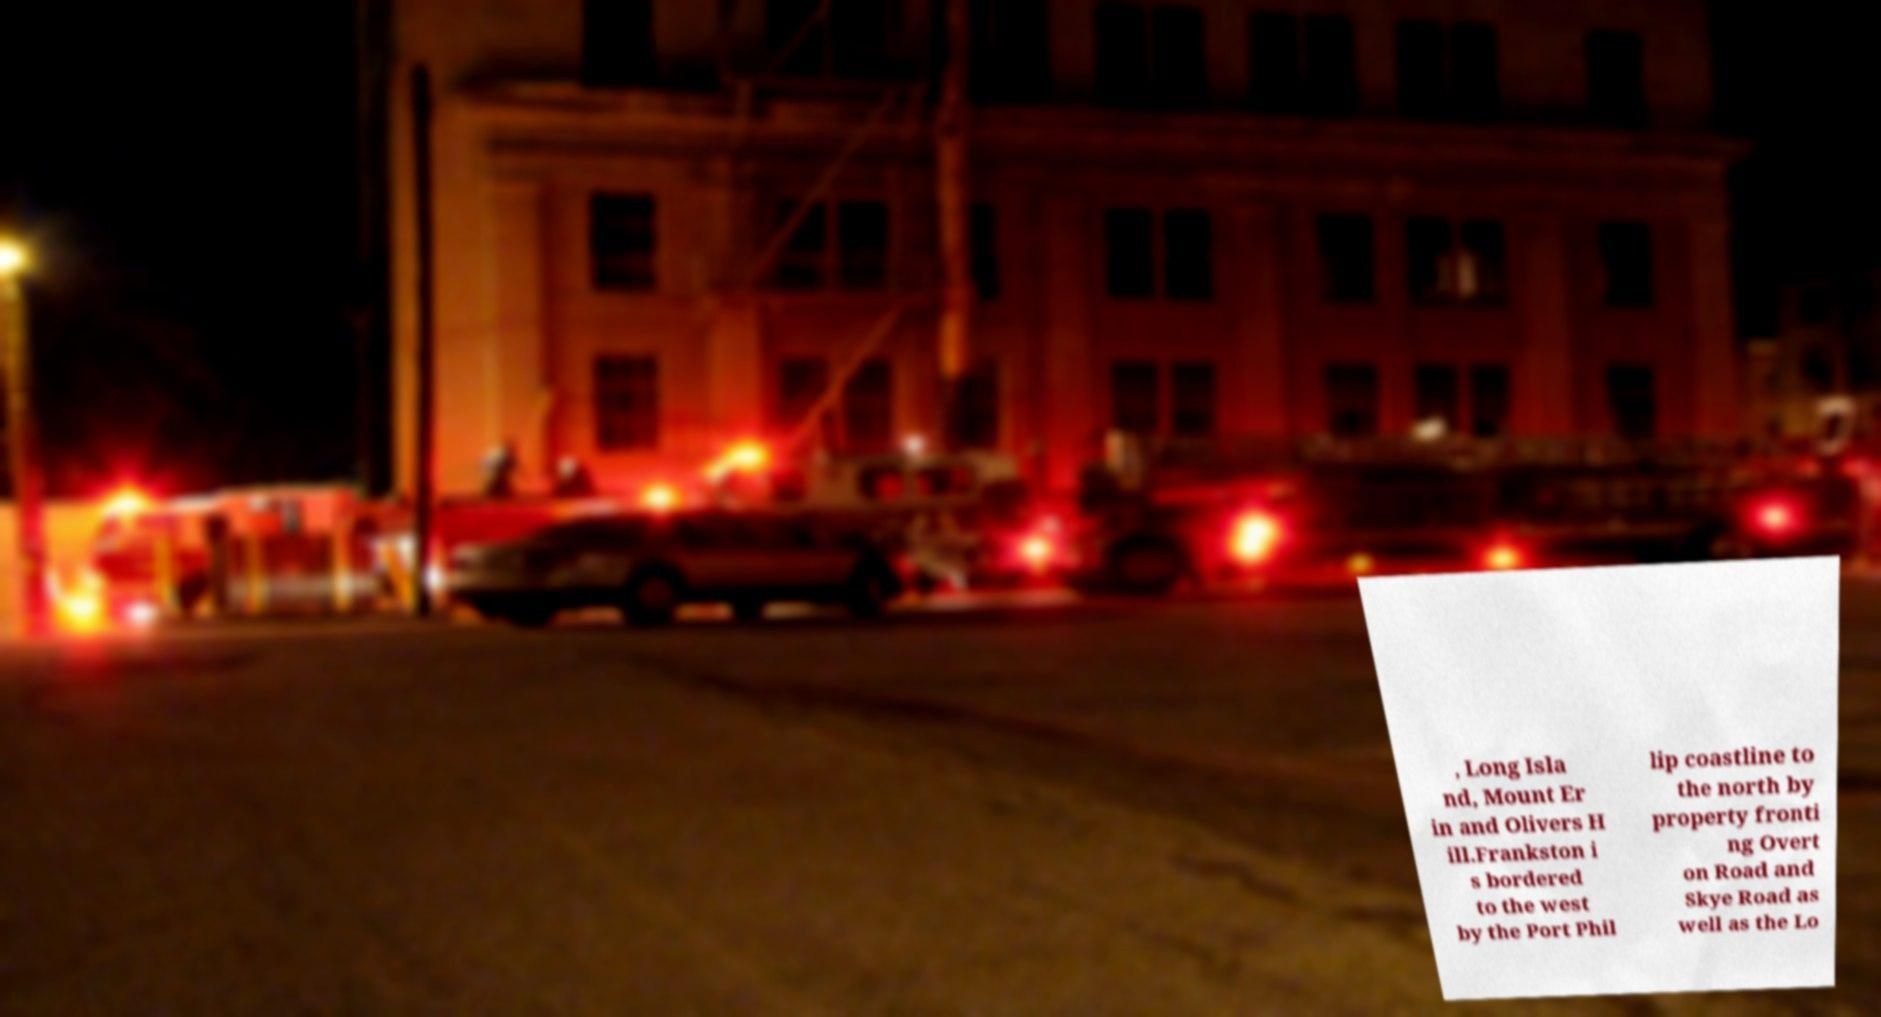I need the written content from this picture converted into text. Can you do that? , Long Isla nd, Mount Er in and Olivers H ill.Frankston i s bordered to the west by the Port Phil lip coastline to the north by property fronti ng Overt on Road and Skye Road as well as the Lo 